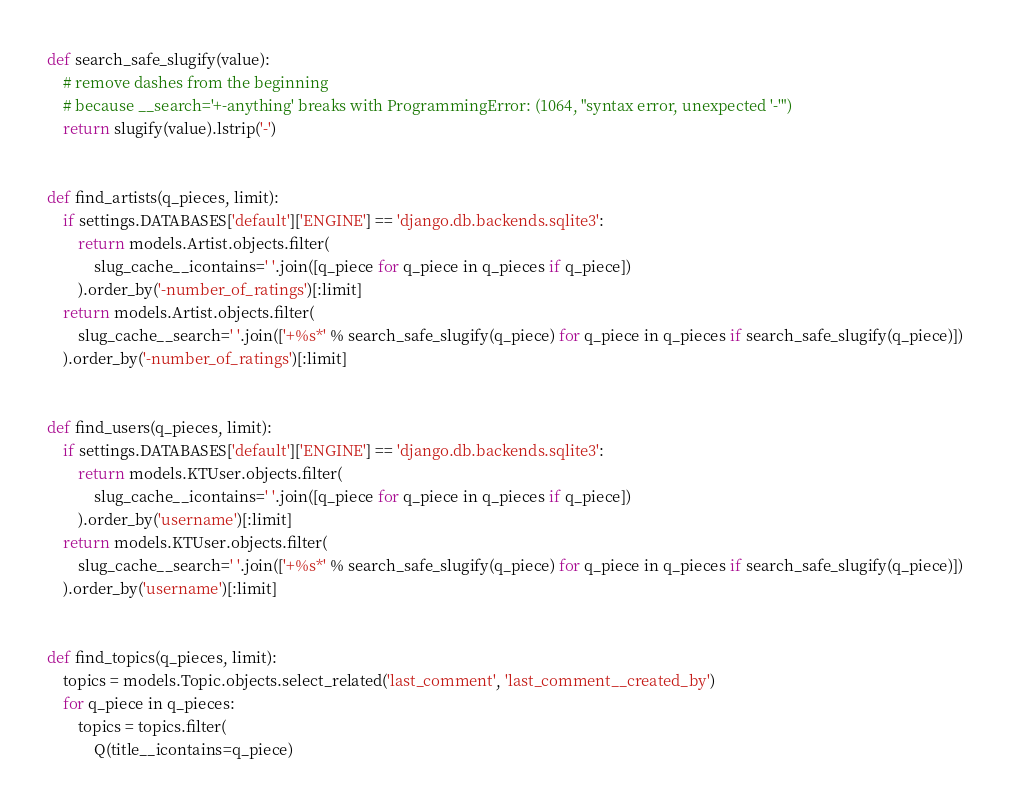Convert code to text. <code><loc_0><loc_0><loc_500><loc_500><_Python_>

def search_safe_slugify(value):
    # remove dashes from the beginning
    # because __search='+-anything' breaks with ProgrammingError: (1064, "syntax error, unexpected '-'")
    return slugify(value).lstrip('-')


def find_artists(q_pieces, limit):
    if settings.DATABASES['default']['ENGINE'] == 'django.db.backends.sqlite3':
        return models.Artist.objects.filter(
            slug_cache__icontains=' '.join([q_piece for q_piece in q_pieces if q_piece])
        ).order_by('-number_of_ratings')[:limit]
    return models.Artist.objects.filter(
        slug_cache__search=' '.join(['+%s*' % search_safe_slugify(q_piece) for q_piece in q_pieces if search_safe_slugify(q_piece)])
    ).order_by('-number_of_ratings')[:limit]


def find_users(q_pieces, limit):
    if settings.DATABASES['default']['ENGINE'] == 'django.db.backends.sqlite3':
        return models.KTUser.objects.filter(
            slug_cache__icontains=' '.join([q_piece for q_piece in q_pieces if q_piece])
        ).order_by('username')[:limit]
    return models.KTUser.objects.filter(
        slug_cache__search=' '.join(['+%s*' % search_safe_slugify(q_piece) for q_piece in q_pieces if search_safe_slugify(q_piece)])
    ).order_by('username')[:limit]


def find_topics(q_pieces, limit):
    topics = models.Topic.objects.select_related('last_comment', 'last_comment__created_by')
    for q_piece in q_pieces:
        topics = topics.filter(
            Q(title__icontains=q_piece)</code> 